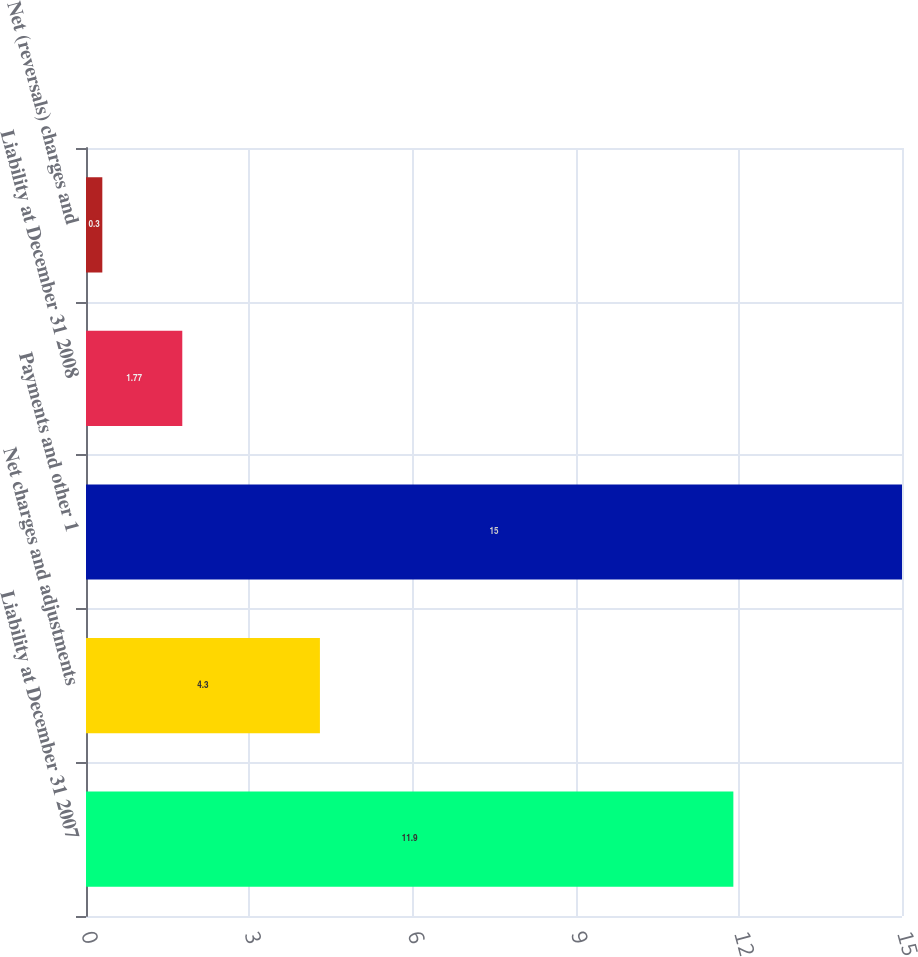<chart> <loc_0><loc_0><loc_500><loc_500><bar_chart><fcel>Liability at December 31 2007<fcel>Net charges and adjustments<fcel>Payments and other 1<fcel>Liability at December 31 2008<fcel>Net (reversals) charges and<nl><fcel>11.9<fcel>4.3<fcel>15<fcel>1.77<fcel>0.3<nl></chart> 